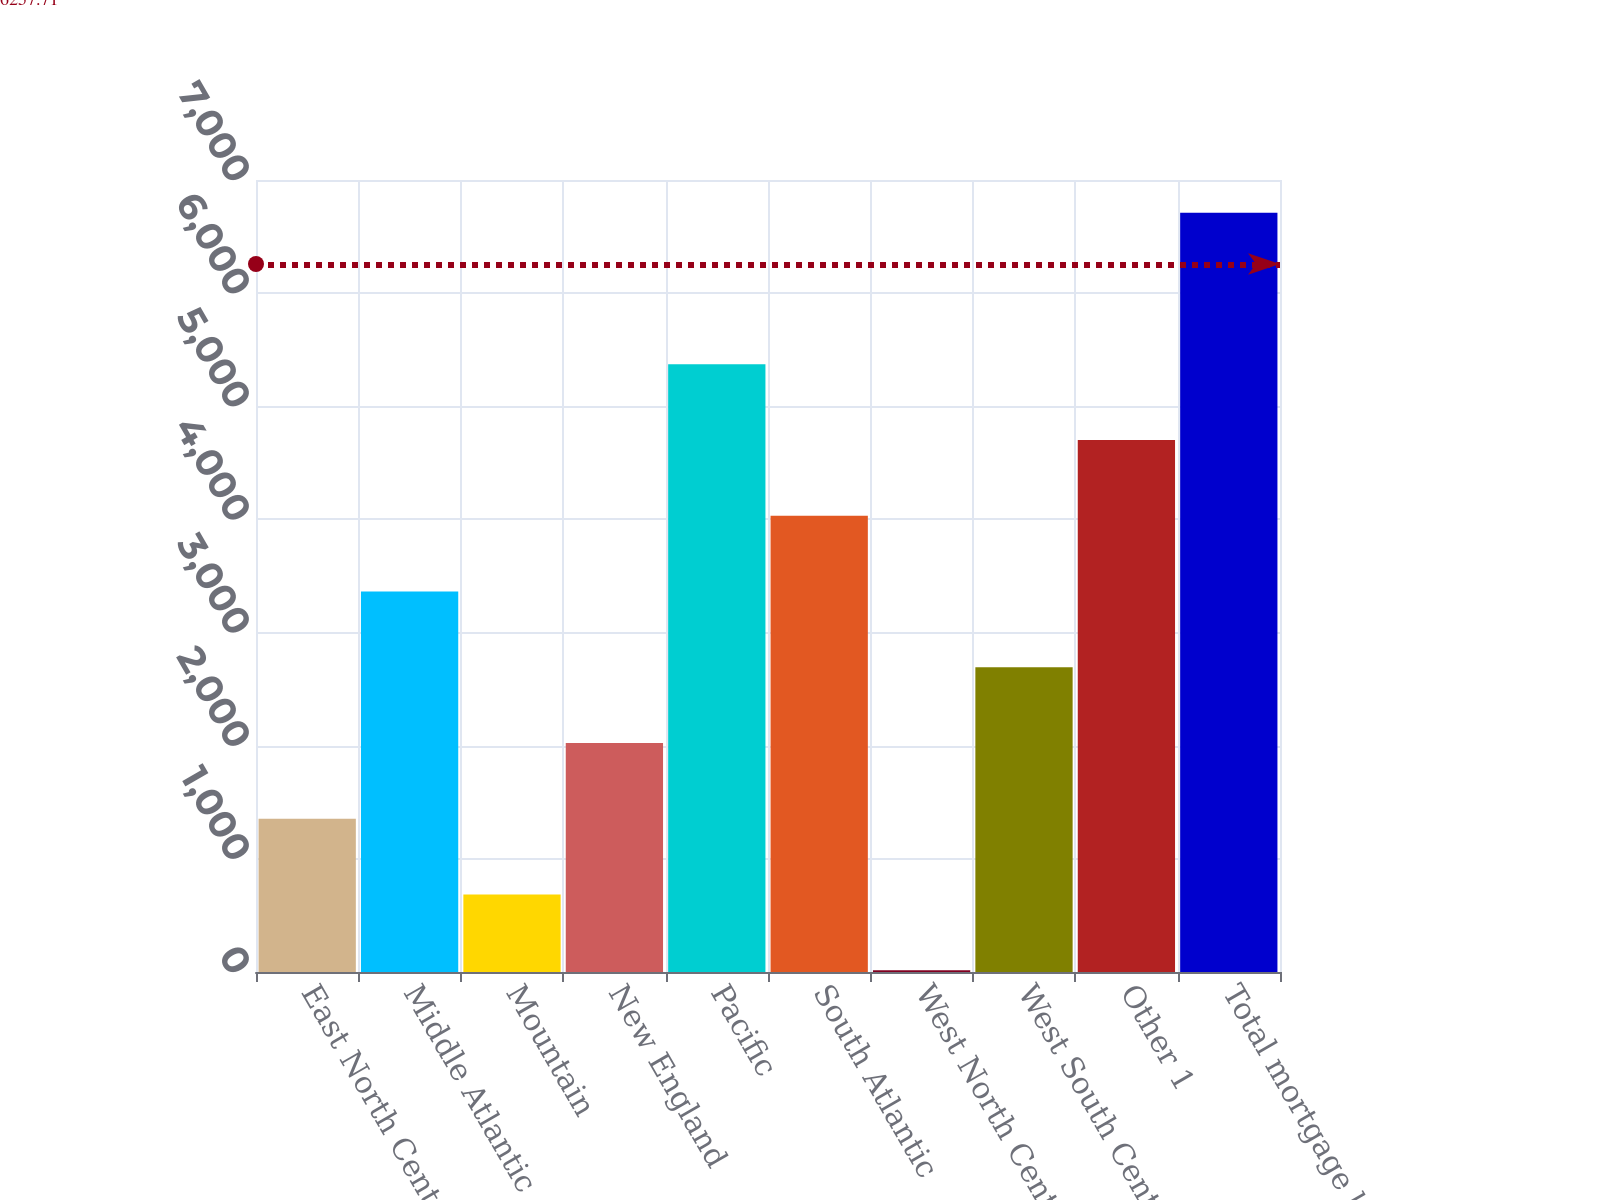Convert chart. <chart><loc_0><loc_0><loc_500><loc_500><bar_chart><fcel>East North Central<fcel>Middle Atlantic<fcel>Mountain<fcel>New England<fcel>Pacific<fcel>South Atlantic<fcel>West North Central<fcel>West South Central<fcel>Other 1<fcel>Total mortgage loans<nl><fcel>1355<fcel>3363.5<fcel>685.5<fcel>2024.5<fcel>5372<fcel>4033<fcel>16<fcel>2694<fcel>4702.5<fcel>6711<nl></chart> 